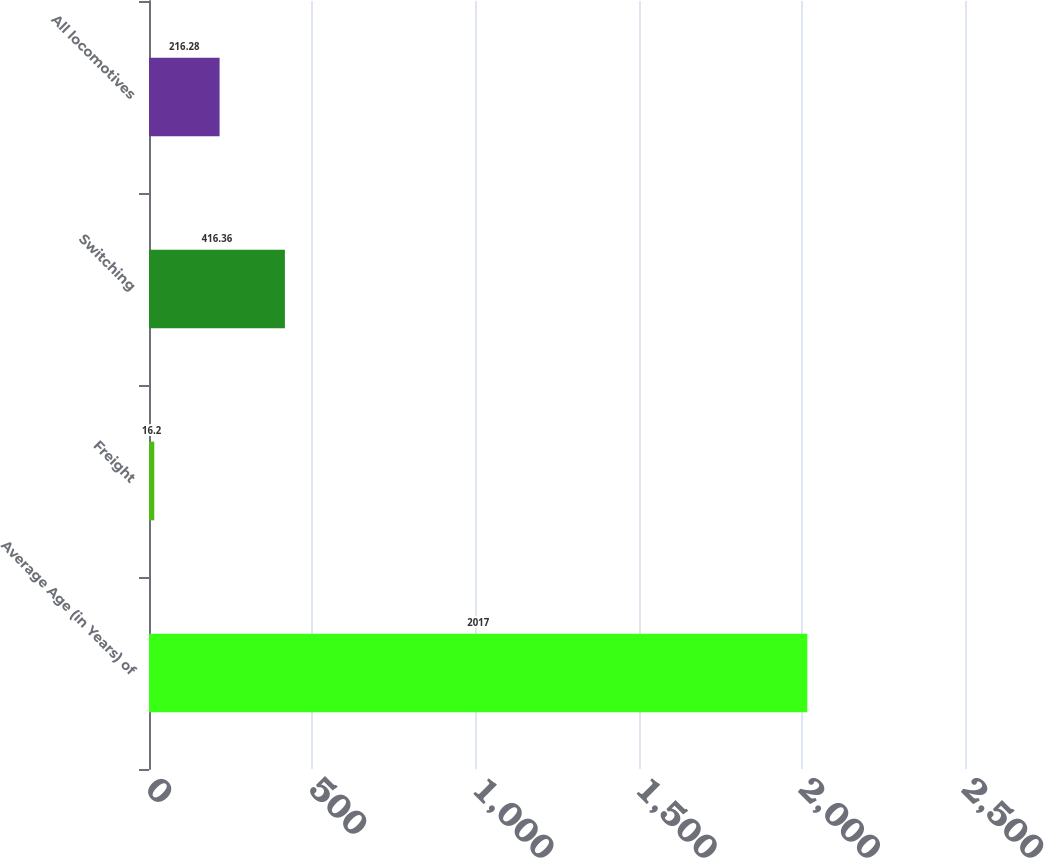Convert chart. <chart><loc_0><loc_0><loc_500><loc_500><bar_chart><fcel>Average Age (in Years) of<fcel>Freight<fcel>Switching<fcel>All locomotives<nl><fcel>2017<fcel>16.2<fcel>416.36<fcel>216.28<nl></chart> 